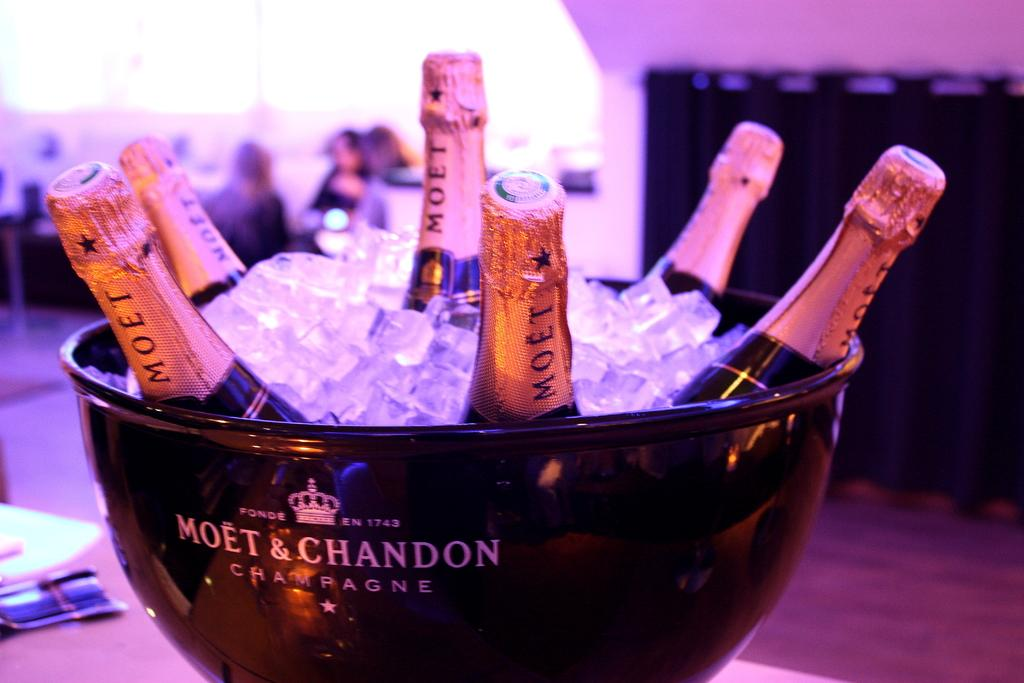<image>
Share a concise interpretation of the image provided. Moet & Chandon champagne bowl full of Moet champagne. 